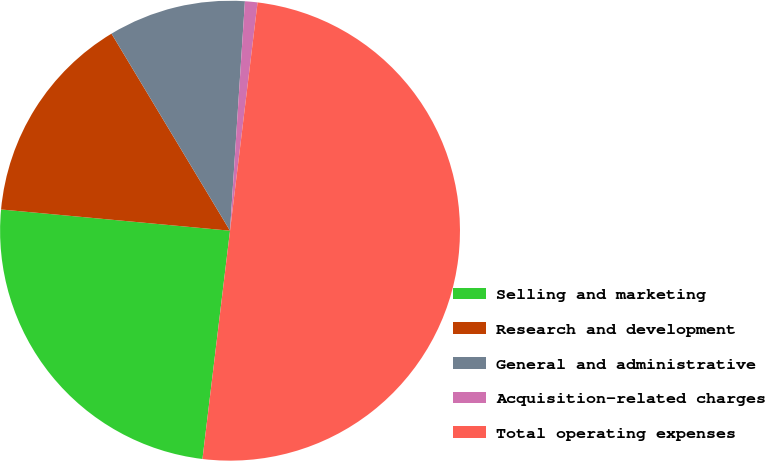Convert chart. <chart><loc_0><loc_0><loc_500><loc_500><pie_chart><fcel>Selling and marketing<fcel>Research and development<fcel>General and administrative<fcel>Acquisition-related charges<fcel>Total operating expenses<nl><fcel>24.56%<fcel>14.91%<fcel>9.65%<fcel>0.88%<fcel>50.0%<nl></chart> 